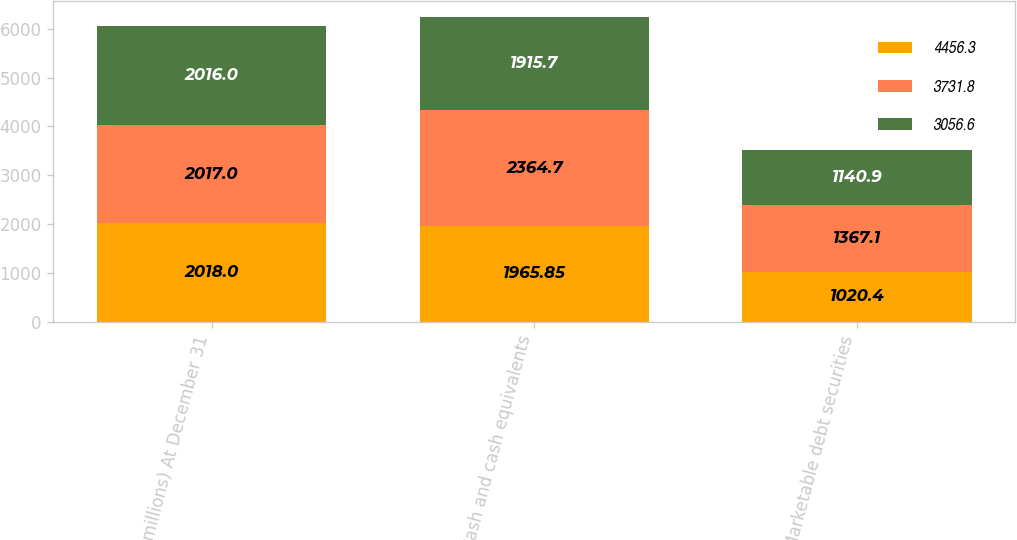<chart> <loc_0><loc_0><loc_500><loc_500><stacked_bar_chart><ecel><fcel>( in millions) At December 31<fcel>Cash and cash equivalents<fcel>Marketable debt securities<nl><fcel>4456.3<fcel>2018<fcel>1965.85<fcel>1020.4<nl><fcel>3731.8<fcel>2017<fcel>2364.7<fcel>1367.1<nl><fcel>3056.6<fcel>2016<fcel>1915.7<fcel>1140.9<nl></chart> 